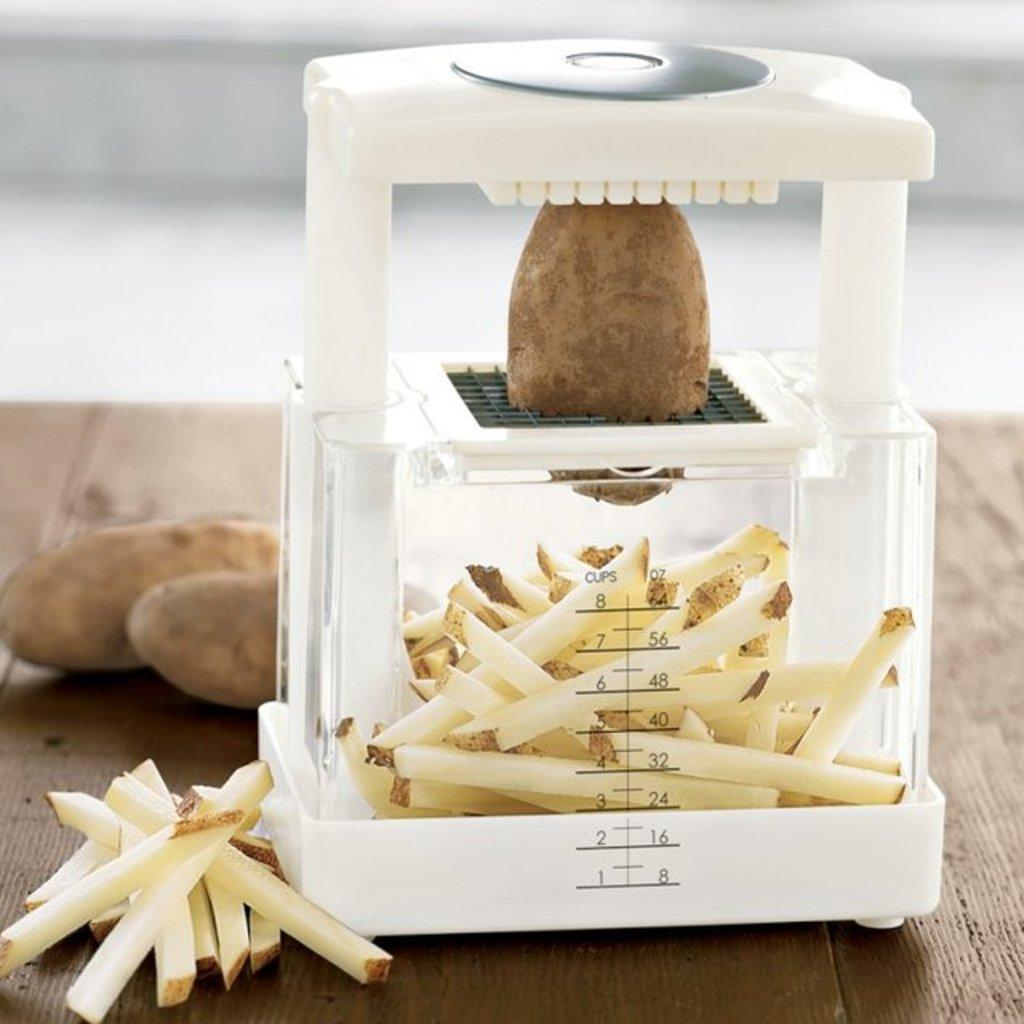What is the main object in the image? There is a vegetable cutter in the image. What is being prepared with the vegetable cutter? A potato is placed between the blades of the vegetable cutter. What is the purpose of the chopped vegetables in the container? The chopped vegetables are likely to be used for cooking or as a side dish. Can you see a worm wearing a scarf in the vegetable cutter? No, there is no worm or scarf present in the image. The image only shows a vegetable cutter with a potato between its blades and chopped vegetables in a container below. 